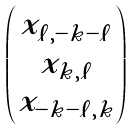<formula> <loc_0><loc_0><loc_500><loc_500>\begin{pmatrix} x _ { \ell , - k - \ell } \\ x _ { k , \ell } \\ x _ { - k - \ell , k } \\ \end{pmatrix}</formula> 